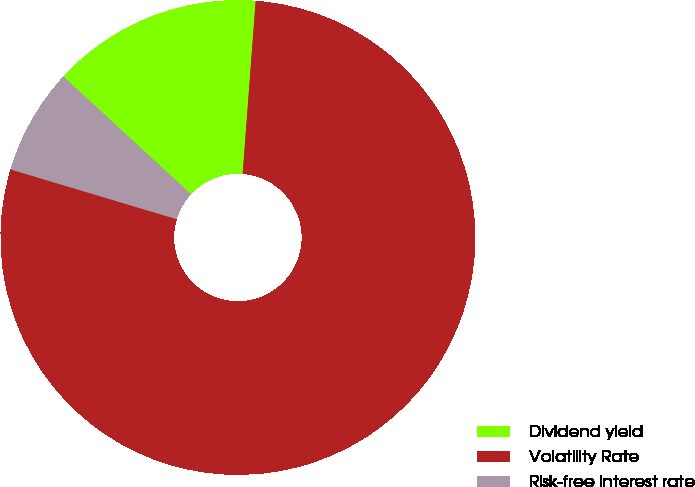Convert chart to OTSL. <chart><loc_0><loc_0><loc_500><loc_500><pie_chart><fcel>Dividend yield<fcel>Volatility Rate<fcel>Risk-free interest rate<nl><fcel>14.34%<fcel>78.44%<fcel>7.22%<nl></chart> 